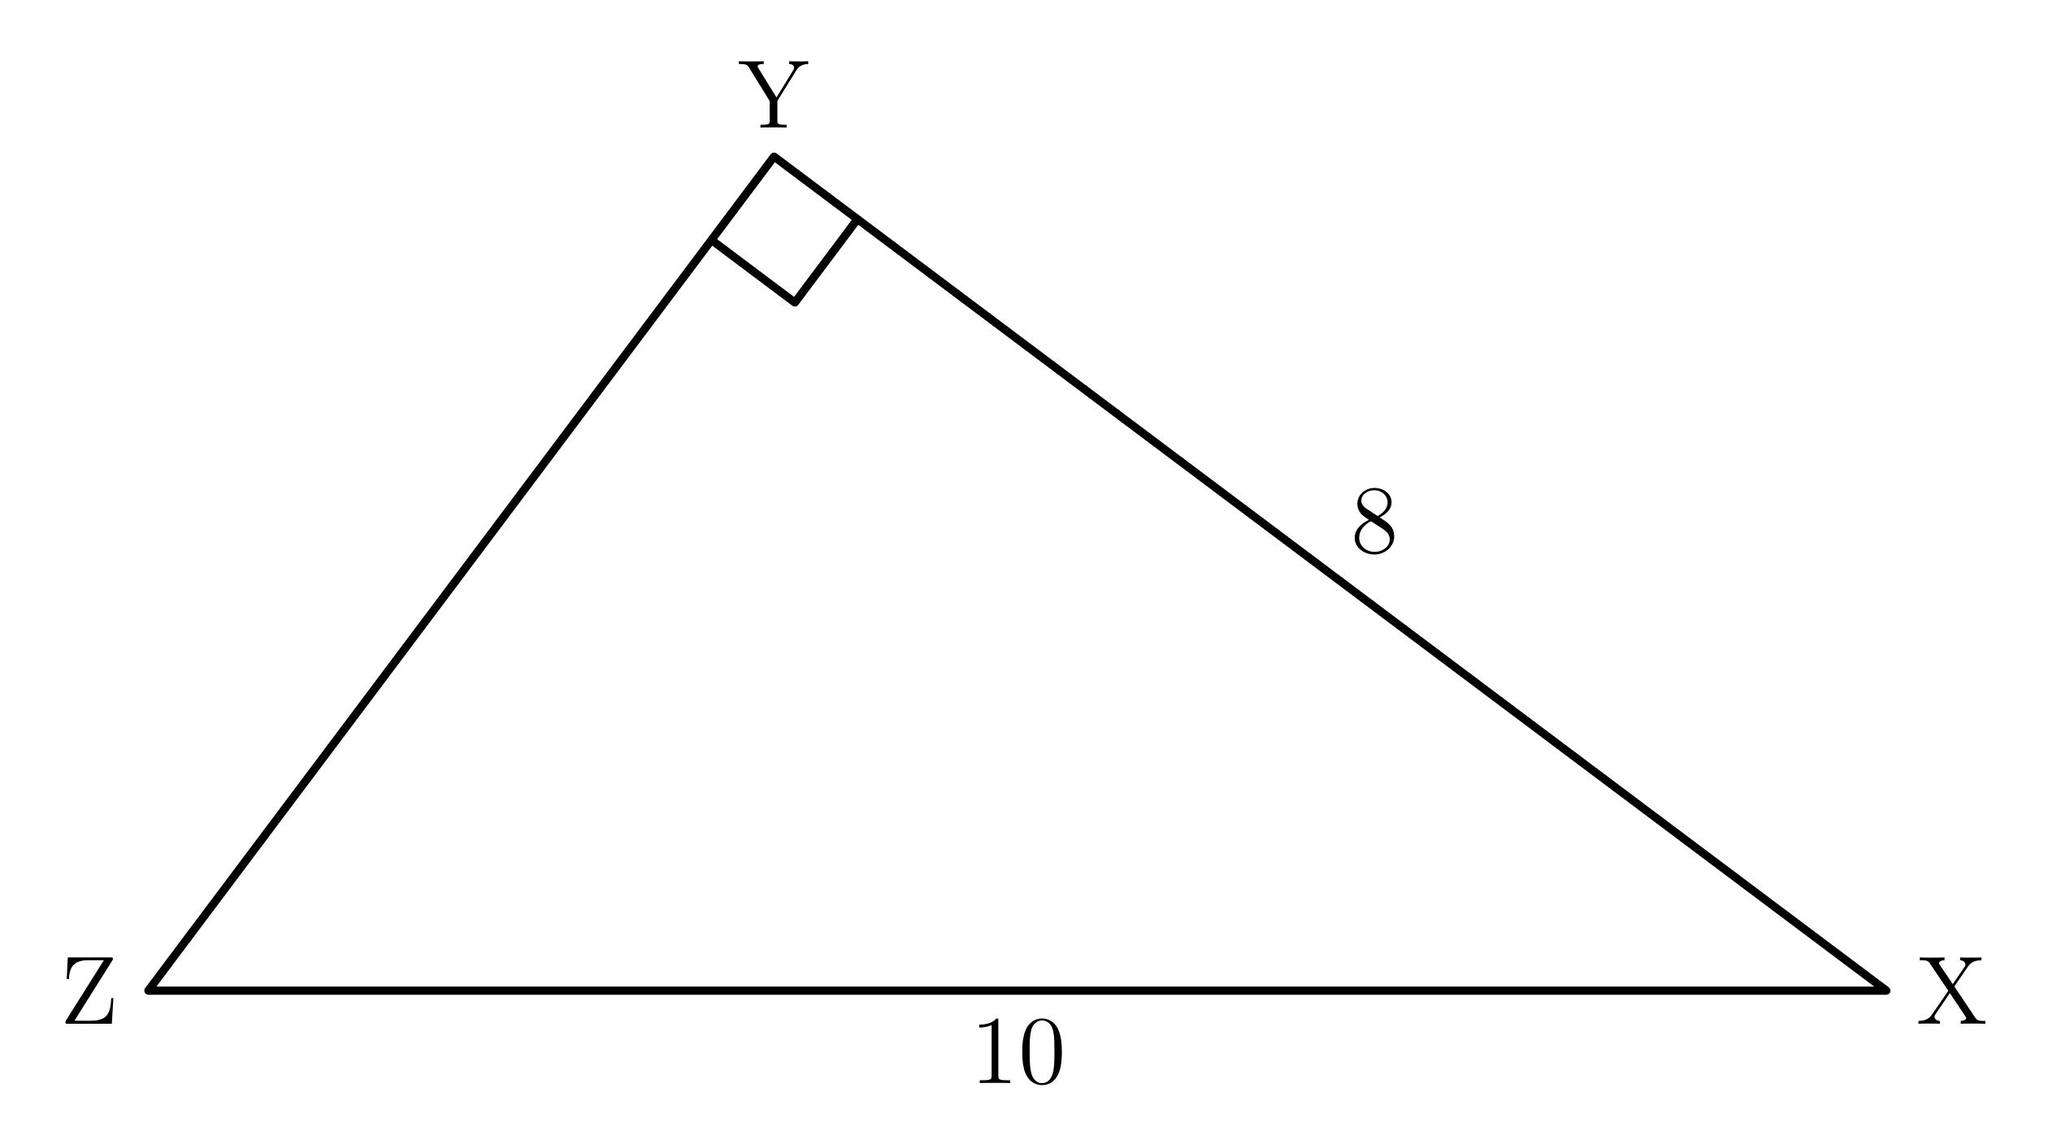In right triangle $XYZ$, shown below, what is $\sin{X}$?

 Answer is \frac{3}{5}. 